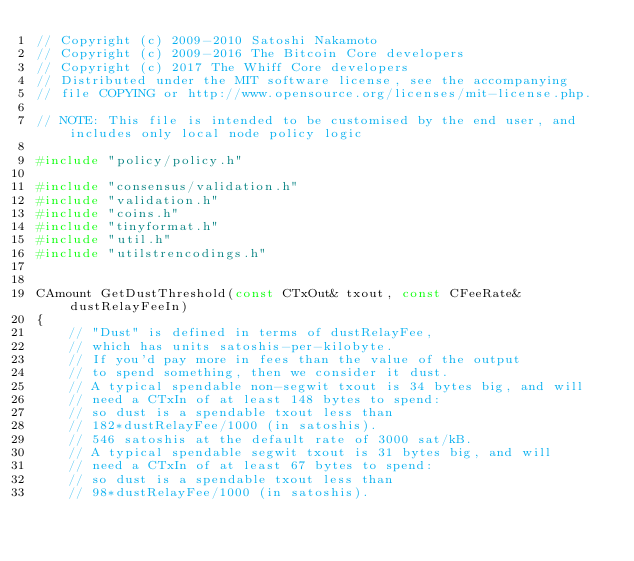<code> <loc_0><loc_0><loc_500><loc_500><_C++_>// Copyright (c) 2009-2010 Satoshi Nakamoto
// Copyright (c) 2009-2016 The Bitcoin Core developers
// Copyright (c) 2017 The Whiff Core developers
// Distributed under the MIT software license, see the accompanying
// file COPYING or http://www.opensource.org/licenses/mit-license.php.

// NOTE: This file is intended to be customised by the end user, and includes only local node policy logic

#include "policy/policy.h"

#include "consensus/validation.h"
#include "validation.h"
#include "coins.h"
#include "tinyformat.h"
#include "util.h"
#include "utilstrencodings.h"


CAmount GetDustThreshold(const CTxOut& txout, const CFeeRate& dustRelayFeeIn)
{
    // "Dust" is defined in terms of dustRelayFee,
    // which has units satoshis-per-kilobyte.
    // If you'd pay more in fees than the value of the output
    // to spend something, then we consider it dust.
    // A typical spendable non-segwit txout is 34 bytes big, and will
    // need a CTxIn of at least 148 bytes to spend:
    // so dust is a spendable txout less than
    // 182*dustRelayFee/1000 (in satoshis).
    // 546 satoshis at the default rate of 3000 sat/kB.
    // A typical spendable segwit txout is 31 bytes big, and will
    // need a CTxIn of at least 67 bytes to spend:
    // so dust is a spendable txout less than
    // 98*dustRelayFee/1000 (in satoshis).</code> 